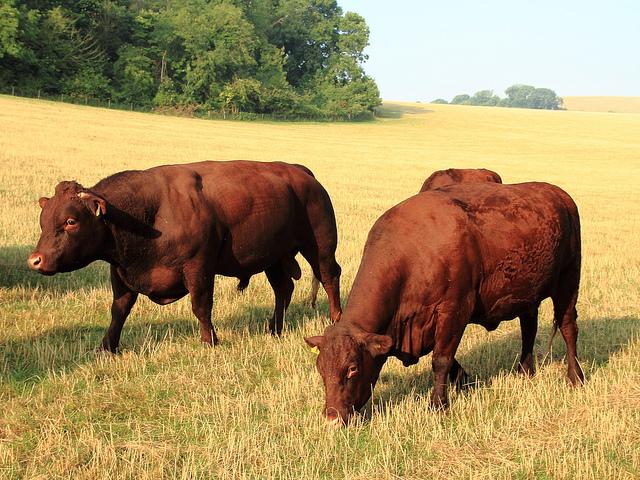Are the cows hungry?
Answer briefly. Yes. How many cows are eating?
Quick response, please. 3. Is the grass dry?
Answer briefly. Yes. Why is the cow on the right in motion?
Write a very short answer. Walking. 